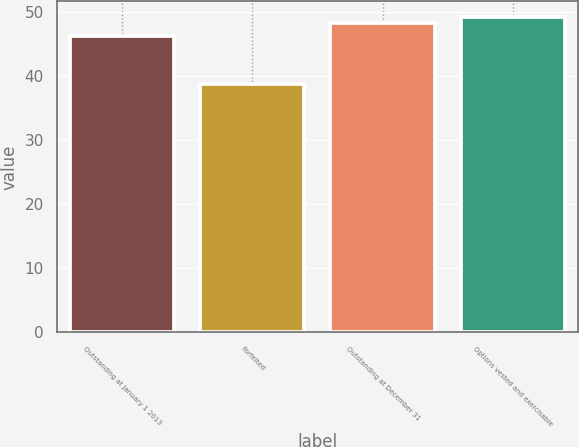<chart> <loc_0><loc_0><loc_500><loc_500><bar_chart><fcel>Outstanding at January 1 2013<fcel>Forfeited<fcel>Outstanding at December 31<fcel>Options vested and exercisable<nl><fcel>46.22<fcel>38.73<fcel>48.23<fcel>49.18<nl></chart> 